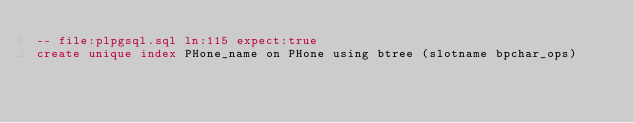<code> <loc_0><loc_0><loc_500><loc_500><_SQL_>-- file:plpgsql.sql ln:115 expect:true
create unique index PHone_name on PHone using btree (slotname bpchar_ops)
</code> 